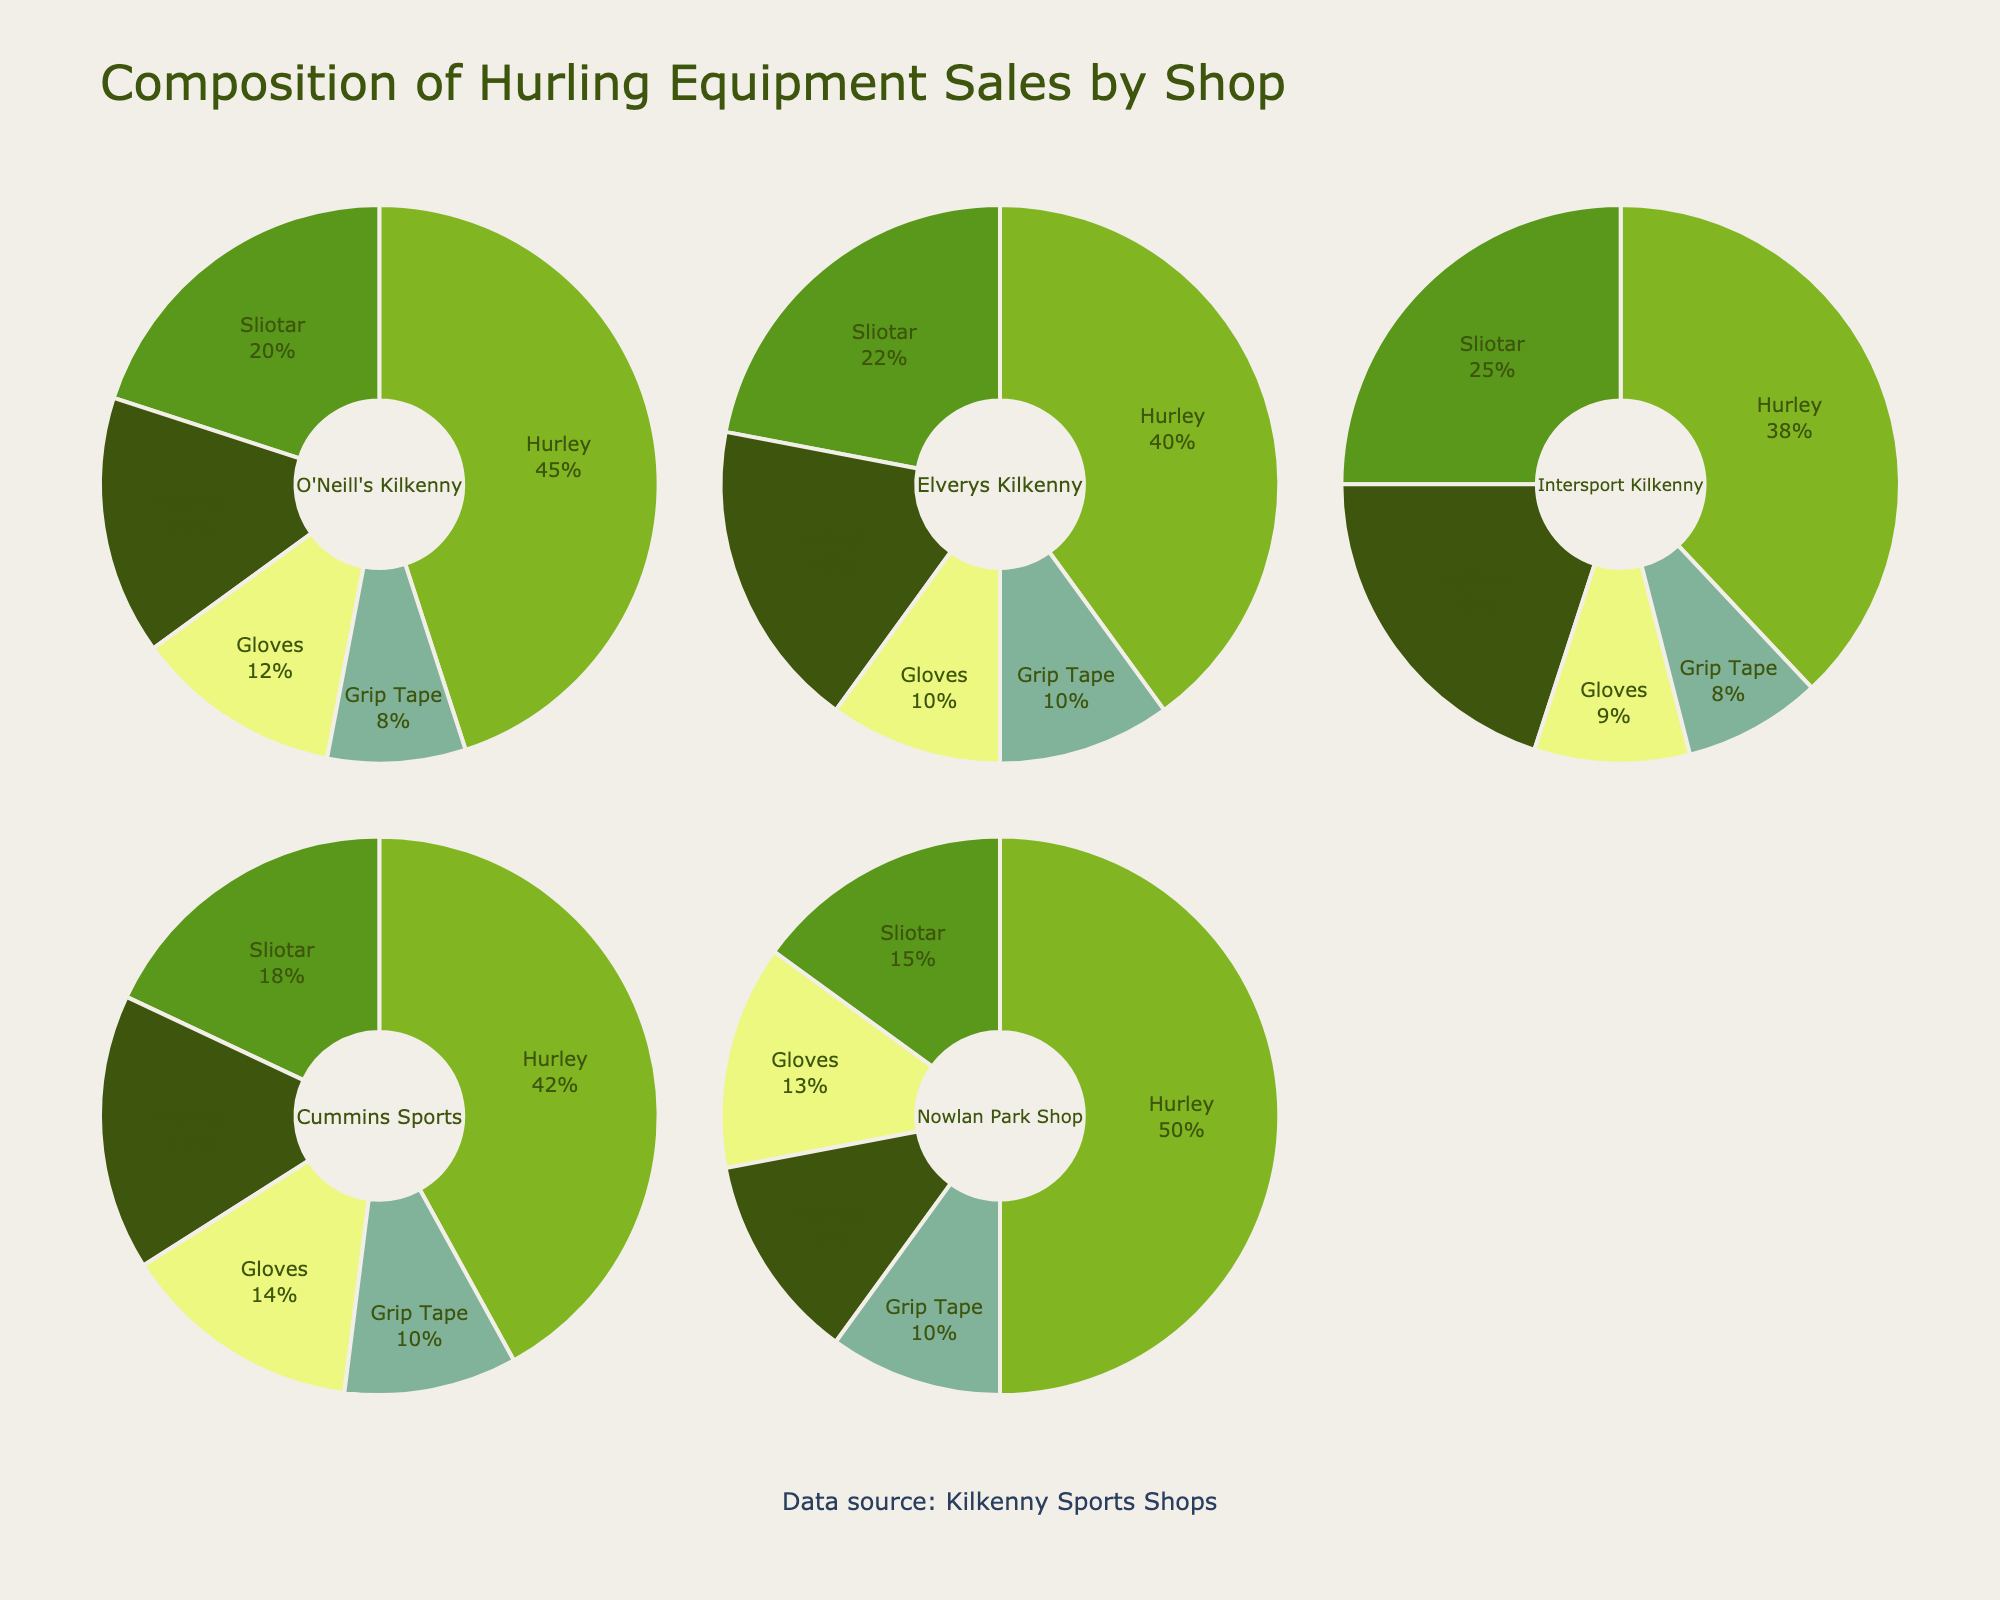What is the total percentage of sales composed of Hurleys in O'Neill's Kilkenny? According to the pie chart for O'Neill's Kilkenny, the Hurley segment shows 45%.
Answer: 45% Which shop has the highest percentage of Hurley sales? By looking at all the pie charts, Nowlan Park Shop has the highest percentage of Hurley sales, which is 50%.
Answer: Nowlan Park Shop How does the percentage of helmet sales in Elverys Kilkenny compare to Intersport Kilkenny? Elverys Kilkenny shows an 18% helmet sales, while Intersport Kilkenny shows 20%. Comparing these, Intersport Kilkenny has a higher percentage of helmet sales.
Answer: Intersport Kilkenny has a higher percentage What is the average percentage of sliotar sales across all shops? The percentages of sliotar sales are 20%, 22%, 25%, 18%, and 15%. The average is calculated as (20 + 22 + 25 + 18 + 15) / 5 = 100 / 5 = 20%.
Answer: 20% Which shop has the lowest percentage of glove sales? By examining the pie charts, Intersport Kilkenny has the lowest percentage of glove sales, at 9%.
Answer: Intersport Kilkenny What is the combined percentage of grip tape sales in Cummins Sports and Nowlan Park Shop? Cummins Sports shows 10% for grip tape and Nowlan Park Shop also shows 10%. Summing these gives 10% + 10% = 20%.
Answer: 20% In which shop do helmet sales account for the smallest proportion of hurling equipment sales? According to the pie charts, Nowlan Park Shop has the smallest proportion of helmet sales at 12%.
Answer: Nowlan Park Shop Compare the percentage of Hurley and Sliotar sales in Elverys Kilkenny. In Elverys Kilkenny, Hurley sales are 40%, and Sliotar sales are 22%. Therefore, Hurley sales are nearly twice the Sliotar sales.
Answer: Hurley sales are nearly twice Sliotar sales Which type of equipment has the most balanced sales percentage across all shops? By comparing each pie chart segment for uniformity, Grip Tape seems to have a sales percentage close to 10% across all shops, making it the most balanced.
Answer: Grip Tape 